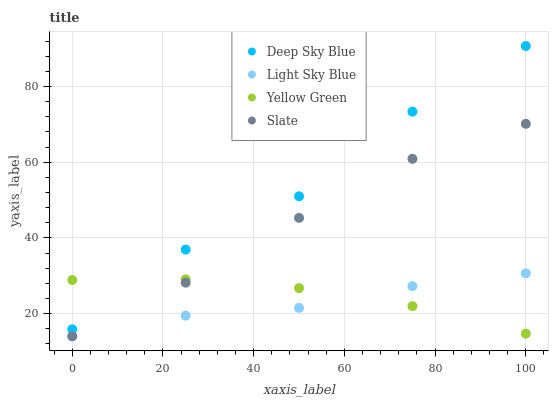Does Light Sky Blue have the minimum area under the curve?
Answer yes or no. Yes. Does Deep Sky Blue have the maximum area under the curve?
Answer yes or no. Yes. Does Yellow Green have the minimum area under the curve?
Answer yes or no. No. Does Yellow Green have the maximum area under the curve?
Answer yes or no. No. Is Yellow Green the smoothest?
Answer yes or no. Yes. Is Deep Sky Blue the roughest?
Answer yes or no. Yes. Is Light Sky Blue the smoothest?
Answer yes or no. No. Is Light Sky Blue the roughest?
Answer yes or no. No. Does Slate have the lowest value?
Answer yes or no. Yes. Does Yellow Green have the lowest value?
Answer yes or no. No. Does Deep Sky Blue have the highest value?
Answer yes or no. Yes. Does Light Sky Blue have the highest value?
Answer yes or no. No. Is Light Sky Blue less than Deep Sky Blue?
Answer yes or no. Yes. Is Deep Sky Blue greater than Light Sky Blue?
Answer yes or no. Yes. Does Yellow Green intersect Deep Sky Blue?
Answer yes or no. Yes. Is Yellow Green less than Deep Sky Blue?
Answer yes or no. No. Is Yellow Green greater than Deep Sky Blue?
Answer yes or no. No. Does Light Sky Blue intersect Deep Sky Blue?
Answer yes or no. No. 